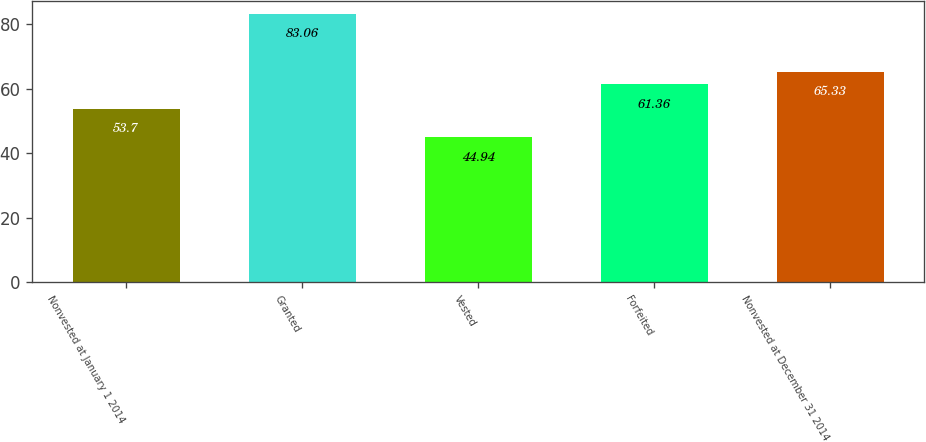Convert chart to OTSL. <chart><loc_0><loc_0><loc_500><loc_500><bar_chart><fcel>Nonvested at January 1 2014<fcel>Granted<fcel>Vested<fcel>Forfeited<fcel>Nonvested at December 31 2014<nl><fcel>53.7<fcel>83.06<fcel>44.94<fcel>61.36<fcel>65.33<nl></chart> 